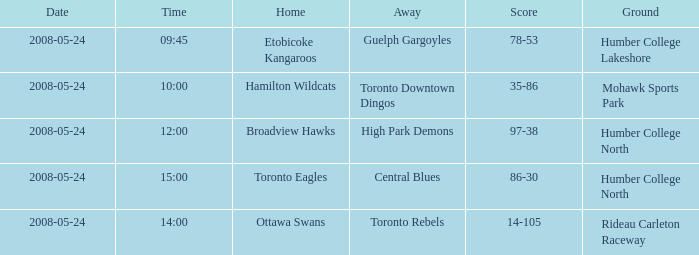Who was the host team of the match at 15:00? Toronto Eagles. 